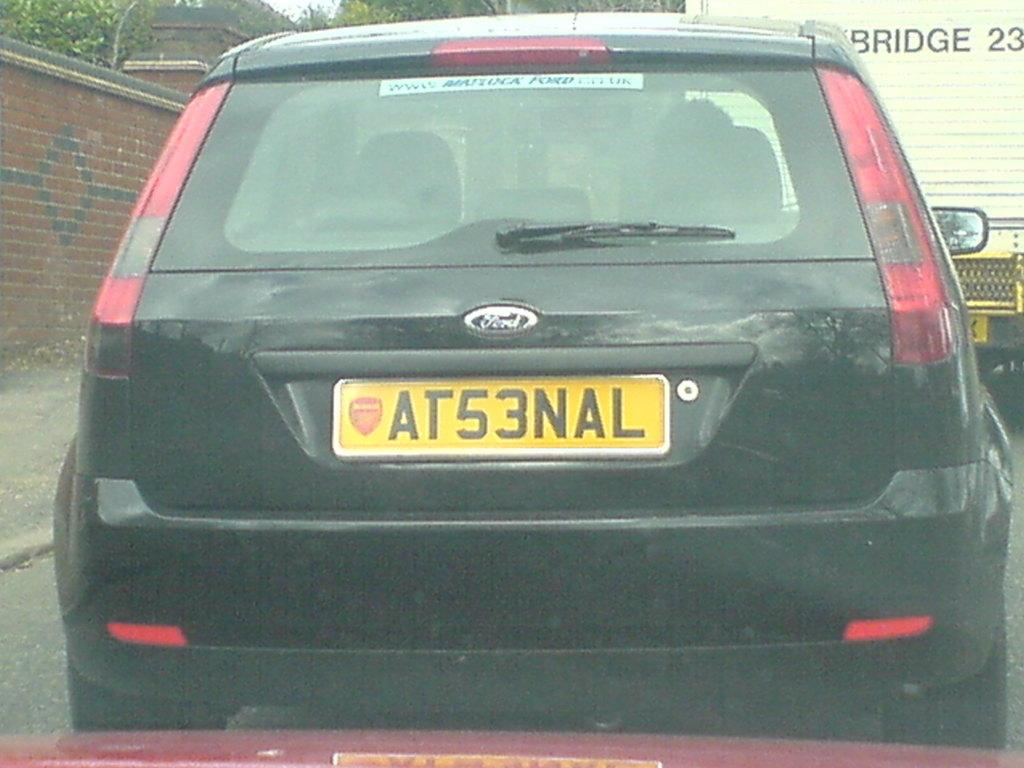<image>
Give a short and clear explanation of the subsequent image. the letter A is on the back of a license plate 